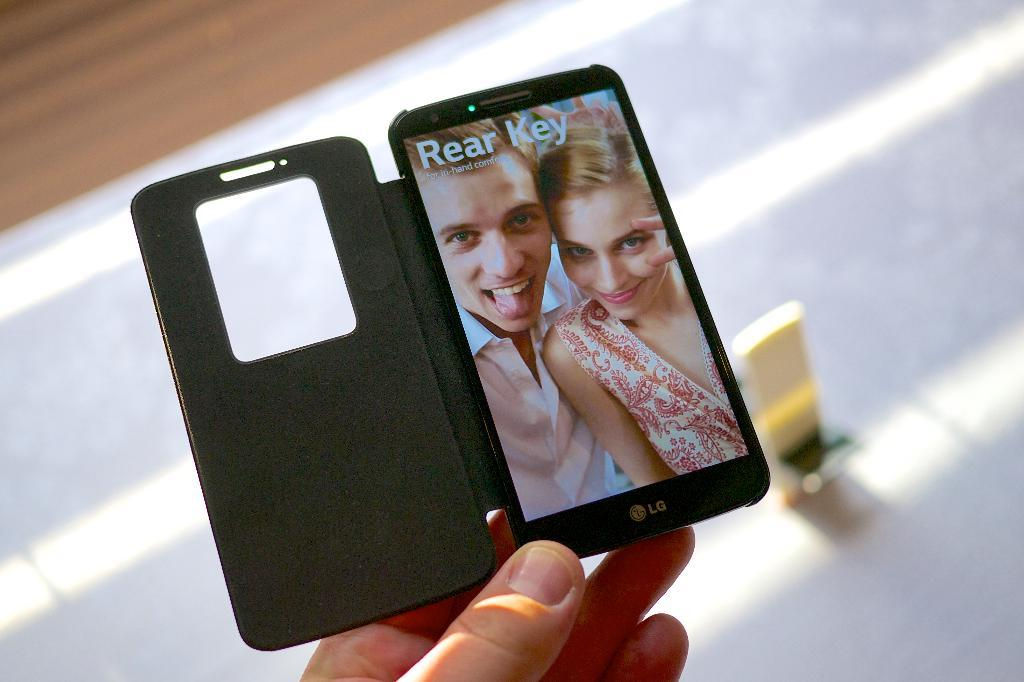<image>
Present a compact description of the photo's key features. an LG phone with a boy and girl along with the words Rear Key 